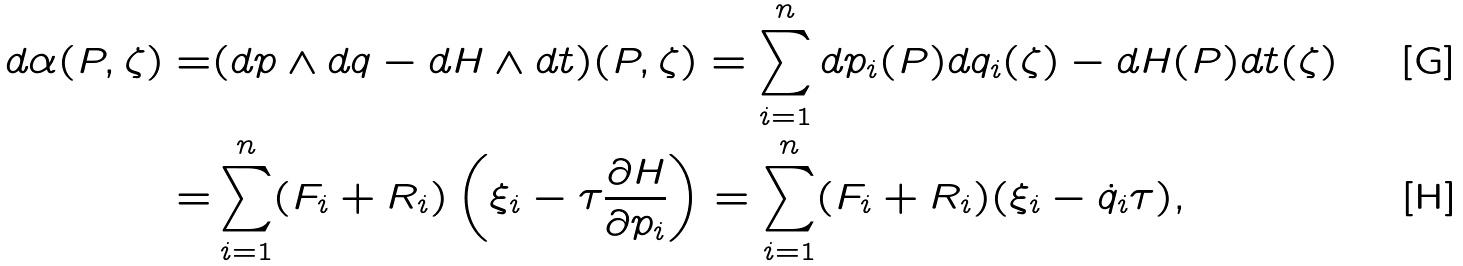<formula> <loc_0><loc_0><loc_500><loc_500>d \alpha ( P , \zeta ) = & ( d p \wedge d q - d H \wedge d t ) ( P , \zeta ) = \sum _ { i = 1 } ^ { n } d p _ { i } ( P ) d q _ { i } ( \zeta ) - d H ( P ) d t ( \zeta ) \\ = & \sum _ { i = 1 } ^ { n } ( F _ { i } + R _ { i } ) \left ( \xi _ { i } - \tau \frac { \partial H } { \partial p _ { i } } \right ) = \sum _ { i = 1 } ^ { n } ( F _ { i } + R _ { i } ) ( \xi _ { i } - \dot { q } _ { i } \tau ) ,</formula> 